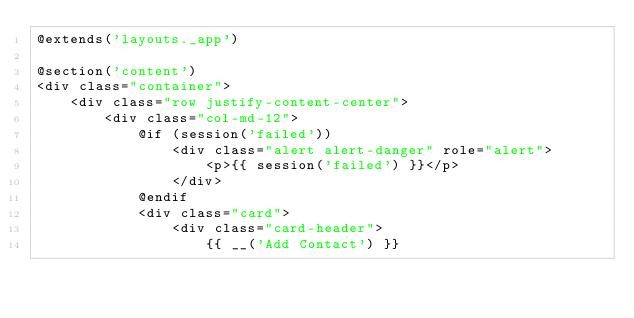<code> <loc_0><loc_0><loc_500><loc_500><_PHP_>@extends('layouts._app')

@section('content')
<div class="container">
    <div class="row justify-content-center">
        <div class="col-md-12">
            @if (session('failed'))
                <div class="alert alert-danger" role="alert">
                    <p>{{ session('failed') }}</p>
                </div>
            @endif
            <div class="card">
                <div class="card-header">
                    {{ __('Add Contact') }}</code> 